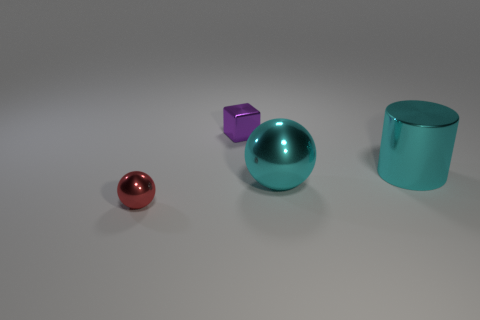Add 2 large cyan spheres. How many objects exist? 6 Subtract all cylinders. How many objects are left? 3 Subtract all purple objects. Subtract all small yellow metallic balls. How many objects are left? 3 Add 3 purple shiny cubes. How many purple shiny cubes are left? 4 Add 4 yellow metallic objects. How many yellow metallic objects exist? 4 Subtract 0 gray cylinders. How many objects are left? 4 